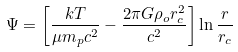<formula> <loc_0><loc_0><loc_500><loc_500>\Psi = \left [ \frac { k T } { \mu m _ { p } c ^ { 2 } } - \frac { 2 \pi G \rho _ { o } r _ { c } ^ { 2 } } { c ^ { 2 } } \right ] \ln \frac { r } { r _ { c } }</formula> 